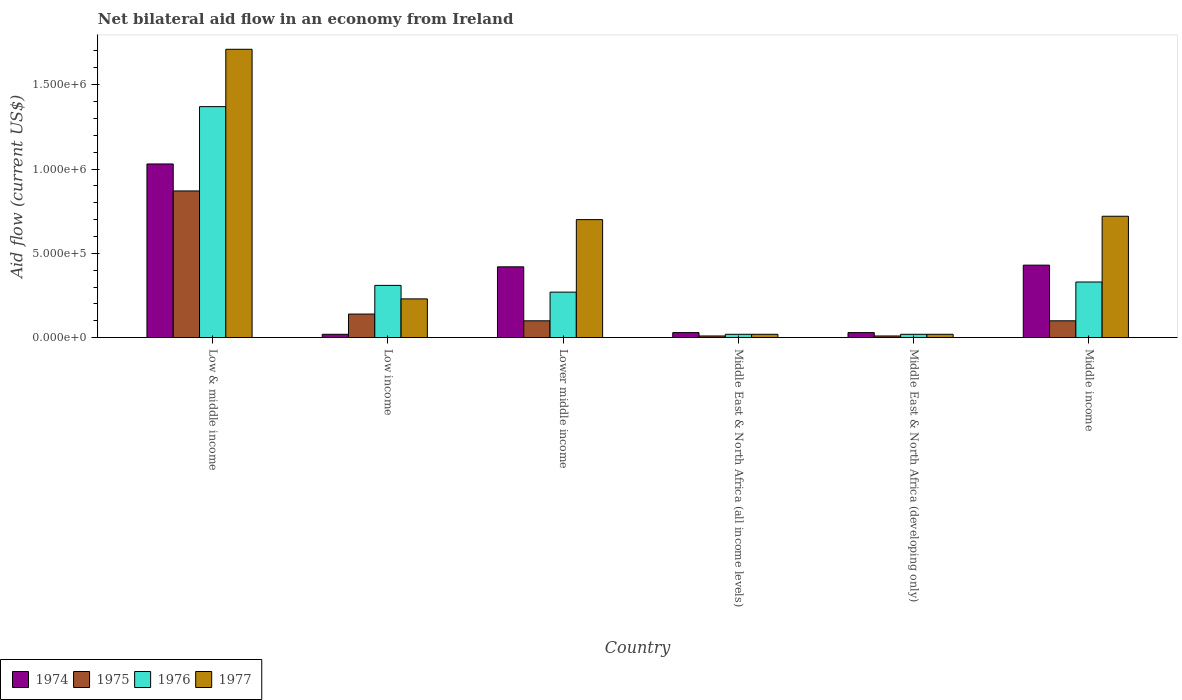Are the number of bars per tick equal to the number of legend labels?
Provide a succinct answer. Yes. Are the number of bars on each tick of the X-axis equal?
Keep it short and to the point. Yes. What is the label of the 1st group of bars from the left?
Provide a short and direct response. Low & middle income. In how many cases, is the number of bars for a given country not equal to the number of legend labels?
Keep it short and to the point. 0. What is the net bilateral aid flow in 1977 in Low income?
Provide a succinct answer. 2.30e+05. Across all countries, what is the maximum net bilateral aid flow in 1976?
Your response must be concise. 1.37e+06. Across all countries, what is the minimum net bilateral aid flow in 1974?
Give a very brief answer. 2.00e+04. In which country was the net bilateral aid flow in 1976 minimum?
Provide a short and direct response. Middle East & North Africa (all income levels). What is the total net bilateral aid flow in 1974 in the graph?
Ensure brevity in your answer.  1.96e+06. What is the difference between the net bilateral aid flow in 1974 in Middle East & North Africa (all income levels) and that in Middle East & North Africa (developing only)?
Offer a terse response. 0. What is the difference between the net bilateral aid flow in 1975 in Lower middle income and the net bilateral aid flow in 1974 in Low & middle income?
Offer a very short reply. -9.30e+05. What is the average net bilateral aid flow in 1975 per country?
Provide a succinct answer. 2.05e+05. What is the difference between the net bilateral aid flow of/in 1975 and net bilateral aid flow of/in 1976 in Lower middle income?
Give a very brief answer. -1.70e+05. In how many countries, is the net bilateral aid flow in 1975 greater than 800000 US$?
Ensure brevity in your answer.  1. What is the ratio of the net bilateral aid flow in 1977 in Low income to that in Middle East & North Africa (all income levels)?
Give a very brief answer. 11.5. Is the net bilateral aid flow in 1975 in Lower middle income less than that in Middle East & North Africa (all income levels)?
Your answer should be compact. No. Is the difference between the net bilateral aid flow in 1975 in Low income and Middle East & North Africa (developing only) greater than the difference between the net bilateral aid flow in 1976 in Low income and Middle East & North Africa (developing only)?
Ensure brevity in your answer.  No. What is the difference between the highest and the second highest net bilateral aid flow in 1976?
Offer a terse response. 1.04e+06. What is the difference between the highest and the lowest net bilateral aid flow in 1976?
Your answer should be compact. 1.35e+06. Is it the case that in every country, the sum of the net bilateral aid flow in 1974 and net bilateral aid flow in 1977 is greater than the sum of net bilateral aid flow in 1976 and net bilateral aid flow in 1975?
Your answer should be compact. No. What does the 2nd bar from the left in Middle income represents?
Offer a very short reply. 1975. What does the 3rd bar from the right in Low income represents?
Ensure brevity in your answer.  1975. Is it the case that in every country, the sum of the net bilateral aid flow in 1975 and net bilateral aid flow in 1977 is greater than the net bilateral aid flow in 1974?
Make the answer very short. No. Are all the bars in the graph horizontal?
Provide a short and direct response. No. Where does the legend appear in the graph?
Offer a terse response. Bottom left. How many legend labels are there?
Give a very brief answer. 4. How are the legend labels stacked?
Make the answer very short. Horizontal. What is the title of the graph?
Give a very brief answer. Net bilateral aid flow in an economy from Ireland. What is the label or title of the Y-axis?
Offer a very short reply. Aid flow (current US$). What is the Aid flow (current US$) in 1974 in Low & middle income?
Provide a succinct answer. 1.03e+06. What is the Aid flow (current US$) in 1975 in Low & middle income?
Make the answer very short. 8.70e+05. What is the Aid flow (current US$) in 1976 in Low & middle income?
Offer a very short reply. 1.37e+06. What is the Aid flow (current US$) of 1977 in Low & middle income?
Provide a short and direct response. 1.71e+06. What is the Aid flow (current US$) of 1974 in Low income?
Provide a short and direct response. 2.00e+04. What is the Aid flow (current US$) of 1977 in Low income?
Provide a succinct answer. 2.30e+05. What is the Aid flow (current US$) in 1974 in Lower middle income?
Provide a succinct answer. 4.20e+05. What is the Aid flow (current US$) in 1975 in Lower middle income?
Provide a succinct answer. 1.00e+05. What is the Aid flow (current US$) of 1976 in Lower middle income?
Your answer should be compact. 2.70e+05. What is the Aid flow (current US$) of 1975 in Middle East & North Africa (all income levels)?
Ensure brevity in your answer.  10000. What is the Aid flow (current US$) of 1976 in Middle East & North Africa (all income levels)?
Your answer should be very brief. 2.00e+04. What is the Aid flow (current US$) in 1977 in Middle East & North Africa (all income levels)?
Your response must be concise. 2.00e+04. What is the Aid flow (current US$) of 1974 in Middle East & North Africa (developing only)?
Ensure brevity in your answer.  3.00e+04. What is the Aid flow (current US$) in 1975 in Middle East & North Africa (developing only)?
Give a very brief answer. 10000. What is the Aid flow (current US$) of 1976 in Middle East & North Africa (developing only)?
Keep it short and to the point. 2.00e+04. What is the Aid flow (current US$) in 1977 in Middle East & North Africa (developing only)?
Your response must be concise. 2.00e+04. What is the Aid flow (current US$) in 1975 in Middle income?
Keep it short and to the point. 1.00e+05. What is the Aid flow (current US$) of 1976 in Middle income?
Provide a succinct answer. 3.30e+05. What is the Aid flow (current US$) in 1977 in Middle income?
Provide a short and direct response. 7.20e+05. Across all countries, what is the maximum Aid flow (current US$) in 1974?
Give a very brief answer. 1.03e+06. Across all countries, what is the maximum Aid flow (current US$) in 1975?
Offer a very short reply. 8.70e+05. Across all countries, what is the maximum Aid flow (current US$) of 1976?
Offer a terse response. 1.37e+06. Across all countries, what is the maximum Aid flow (current US$) in 1977?
Provide a short and direct response. 1.71e+06. Across all countries, what is the minimum Aid flow (current US$) in 1974?
Your answer should be compact. 2.00e+04. Across all countries, what is the minimum Aid flow (current US$) of 1976?
Ensure brevity in your answer.  2.00e+04. Across all countries, what is the minimum Aid flow (current US$) in 1977?
Your response must be concise. 2.00e+04. What is the total Aid flow (current US$) in 1974 in the graph?
Offer a very short reply. 1.96e+06. What is the total Aid flow (current US$) in 1975 in the graph?
Keep it short and to the point. 1.23e+06. What is the total Aid flow (current US$) in 1976 in the graph?
Offer a very short reply. 2.32e+06. What is the total Aid flow (current US$) of 1977 in the graph?
Offer a terse response. 3.40e+06. What is the difference between the Aid flow (current US$) in 1974 in Low & middle income and that in Low income?
Offer a very short reply. 1.01e+06. What is the difference between the Aid flow (current US$) in 1975 in Low & middle income and that in Low income?
Offer a terse response. 7.30e+05. What is the difference between the Aid flow (current US$) of 1976 in Low & middle income and that in Low income?
Make the answer very short. 1.06e+06. What is the difference between the Aid flow (current US$) of 1977 in Low & middle income and that in Low income?
Provide a succinct answer. 1.48e+06. What is the difference between the Aid flow (current US$) in 1975 in Low & middle income and that in Lower middle income?
Make the answer very short. 7.70e+05. What is the difference between the Aid flow (current US$) of 1976 in Low & middle income and that in Lower middle income?
Make the answer very short. 1.10e+06. What is the difference between the Aid flow (current US$) of 1977 in Low & middle income and that in Lower middle income?
Ensure brevity in your answer.  1.01e+06. What is the difference between the Aid flow (current US$) in 1974 in Low & middle income and that in Middle East & North Africa (all income levels)?
Provide a succinct answer. 1.00e+06. What is the difference between the Aid flow (current US$) of 1975 in Low & middle income and that in Middle East & North Africa (all income levels)?
Provide a short and direct response. 8.60e+05. What is the difference between the Aid flow (current US$) in 1976 in Low & middle income and that in Middle East & North Africa (all income levels)?
Your response must be concise. 1.35e+06. What is the difference between the Aid flow (current US$) in 1977 in Low & middle income and that in Middle East & North Africa (all income levels)?
Provide a succinct answer. 1.69e+06. What is the difference between the Aid flow (current US$) of 1975 in Low & middle income and that in Middle East & North Africa (developing only)?
Keep it short and to the point. 8.60e+05. What is the difference between the Aid flow (current US$) in 1976 in Low & middle income and that in Middle East & North Africa (developing only)?
Offer a terse response. 1.35e+06. What is the difference between the Aid flow (current US$) in 1977 in Low & middle income and that in Middle East & North Africa (developing only)?
Your answer should be compact. 1.69e+06. What is the difference between the Aid flow (current US$) of 1974 in Low & middle income and that in Middle income?
Offer a terse response. 6.00e+05. What is the difference between the Aid flow (current US$) of 1975 in Low & middle income and that in Middle income?
Keep it short and to the point. 7.70e+05. What is the difference between the Aid flow (current US$) in 1976 in Low & middle income and that in Middle income?
Make the answer very short. 1.04e+06. What is the difference between the Aid flow (current US$) in 1977 in Low & middle income and that in Middle income?
Make the answer very short. 9.90e+05. What is the difference between the Aid flow (current US$) of 1974 in Low income and that in Lower middle income?
Provide a succinct answer. -4.00e+05. What is the difference between the Aid flow (current US$) in 1976 in Low income and that in Lower middle income?
Give a very brief answer. 4.00e+04. What is the difference between the Aid flow (current US$) of 1977 in Low income and that in Lower middle income?
Your response must be concise. -4.70e+05. What is the difference between the Aid flow (current US$) of 1975 in Low income and that in Middle East & North Africa (all income levels)?
Offer a very short reply. 1.30e+05. What is the difference between the Aid flow (current US$) in 1976 in Low income and that in Middle East & North Africa (all income levels)?
Ensure brevity in your answer.  2.90e+05. What is the difference between the Aid flow (current US$) of 1977 in Low income and that in Middle East & North Africa (all income levels)?
Offer a terse response. 2.10e+05. What is the difference between the Aid flow (current US$) of 1974 in Low income and that in Middle East & North Africa (developing only)?
Your response must be concise. -10000. What is the difference between the Aid flow (current US$) of 1975 in Low income and that in Middle East & North Africa (developing only)?
Ensure brevity in your answer.  1.30e+05. What is the difference between the Aid flow (current US$) in 1976 in Low income and that in Middle East & North Africa (developing only)?
Ensure brevity in your answer.  2.90e+05. What is the difference between the Aid flow (current US$) in 1974 in Low income and that in Middle income?
Provide a succinct answer. -4.10e+05. What is the difference between the Aid flow (current US$) of 1976 in Low income and that in Middle income?
Ensure brevity in your answer.  -2.00e+04. What is the difference between the Aid flow (current US$) of 1977 in Low income and that in Middle income?
Give a very brief answer. -4.90e+05. What is the difference between the Aid flow (current US$) in 1976 in Lower middle income and that in Middle East & North Africa (all income levels)?
Make the answer very short. 2.50e+05. What is the difference between the Aid flow (current US$) of 1977 in Lower middle income and that in Middle East & North Africa (all income levels)?
Offer a terse response. 6.80e+05. What is the difference between the Aid flow (current US$) of 1974 in Lower middle income and that in Middle East & North Africa (developing only)?
Provide a succinct answer. 3.90e+05. What is the difference between the Aid flow (current US$) in 1975 in Lower middle income and that in Middle East & North Africa (developing only)?
Give a very brief answer. 9.00e+04. What is the difference between the Aid flow (current US$) of 1976 in Lower middle income and that in Middle East & North Africa (developing only)?
Your answer should be very brief. 2.50e+05. What is the difference between the Aid flow (current US$) of 1977 in Lower middle income and that in Middle East & North Africa (developing only)?
Make the answer very short. 6.80e+05. What is the difference between the Aid flow (current US$) in 1974 in Lower middle income and that in Middle income?
Your answer should be compact. -10000. What is the difference between the Aid flow (current US$) of 1976 in Lower middle income and that in Middle income?
Your answer should be very brief. -6.00e+04. What is the difference between the Aid flow (current US$) of 1977 in Middle East & North Africa (all income levels) and that in Middle East & North Africa (developing only)?
Ensure brevity in your answer.  0. What is the difference between the Aid flow (current US$) of 1974 in Middle East & North Africa (all income levels) and that in Middle income?
Your response must be concise. -4.00e+05. What is the difference between the Aid flow (current US$) of 1975 in Middle East & North Africa (all income levels) and that in Middle income?
Offer a terse response. -9.00e+04. What is the difference between the Aid flow (current US$) in 1976 in Middle East & North Africa (all income levels) and that in Middle income?
Offer a terse response. -3.10e+05. What is the difference between the Aid flow (current US$) in 1977 in Middle East & North Africa (all income levels) and that in Middle income?
Provide a short and direct response. -7.00e+05. What is the difference between the Aid flow (current US$) in 1974 in Middle East & North Africa (developing only) and that in Middle income?
Offer a very short reply. -4.00e+05. What is the difference between the Aid flow (current US$) in 1976 in Middle East & North Africa (developing only) and that in Middle income?
Ensure brevity in your answer.  -3.10e+05. What is the difference between the Aid flow (current US$) in 1977 in Middle East & North Africa (developing only) and that in Middle income?
Your answer should be very brief. -7.00e+05. What is the difference between the Aid flow (current US$) of 1974 in Low & middle income and the Aid flow (current US$) of 1975 in Low income?
Your answer should be compact. 8.90e+05. What is the difference between the Aid flow (current US$) of 1974 in Low & middle income and the Aid flow (current US$) of 1976 in Low income?
Make the answer very short. 7.20e+05. What is the difference between the Aid flow (current US$) in 1975 in Low & middle income and the Aid flow (current US$) in 1976 in Low income?
Your response must be concise. 5.60e+05. What is the difference between the Aid flow (current US$) in 1975 in Low & middle income and the Aid flow (current US$) in 1977 in Low income?
Your response must be concise. 6.40e+05. What is the difference between the Aid flow (current US$) of 1976 in Low & middle income and the Aid flow (current US$) of 1977 in Low income?
Your response must be concise. 1.14e+06. What is the difference between the Aid flow (current US$) in 1974 in Low & middle income and the Aid flow (current US$) in 1975 in Lower middle income?
Your answer should be very brief. 9.30e+05. What is the difference between the Aid flow (current US$) of 1974 in Low & middle income and the Aid flow (current US$) of 1976 in Lower middle income?
Offer a terse response. 7.60e+05. What is the difference between the Aid flow (current US$) in 1975 in Low & middle income and the Aid flow (current US$) in 1977 in Lower middle income?
Your response must be concise. 1.70e+05. What is the difference between the Aid flow (current US$) of 1976 in Low & middle income and the Aid flow (current US$) of 1977 in Lower middle income?
Your response must be concise. 6.70e+05. What is the difference between the Aid flow (current US$) in 1974 in Low & middle income and the Aid flow (current US$) in 1975 in Middle East & North Africa (all income levels)?
Offer a terse response. 1.02e+06. What is the difference between the Aid flow (current US$) in 1974 in Low & middle income and the Aid flow (current US$) in 1976 in Middle East & North Africa (all income levels)?
Your answer should be very brief. 1.01e+06. What is the difference between the Aid flow (current US$) in 1974 in Low & middle income and the Aid flow (current US$) in 1977 in Middle East & North Africa (all income levels)?
Your response must be concise. 1.01e+06. What is the difference between the Aid flow (current US$) in 1975 in Low & middle income and the Aid flow (current US$) in 1976 in Middle East & North Africa (all income levels)?
Offer a terse response. 8.50e+05. What is the difference between the Aid flow (current US$) of 1975 in Low & middle income and the Aid flow (current US$) of 1977 in Middle East & North Africa (all income levels)?
Your response must be concise. 8.50e+05. What is the difference between the Aid flow (current US$) in 1976 in Low & middle income and the Aid flow (current US$) in 1977 in Middle East & North Africa (all income levels)?
Offer a terse response. 1.35e+06. What is the difference between the Aid flow (current US$) in 1974 in Low & middle income and the Aid flow (current US$) in 1975 in Middle East & North Africa (developing only)?
Offer a very short reply. 1.02e+06. What is the difference between the Aid flow (current US$) in 1974 in Low & middle income and the Aid flow (current US$) in 1976 in Middle East & North Africa (developing only)?
Your answer should be very brief. 1.01e+06. What is the difference between the Aid flow (current US$) in 1974 in Low & middle income and the Aid flow (current US$) in 1977 in Middle East & North Africa (developing only)?
Offer a terse response. 1.01e+06. What is the difference between the Aid flow (current US$) in 1975 in Low & middle income and the Aid flow (current US$) in 1976 in Middle East & North Africa (developing only)?
Your answer should be very brief. 8.50e+05. What is the difference between the Aid flow (current US$) of 1975 in Low & middle income and the Aid flow (current US$) of 1977 in Middle East & North Africa (developing only)?
Offer a very short reply. 8.50e+05. What is the difference between the Aid flow (current US$) in 1976 in Low & middle income and the Aid flow (current US$) in 1977 in Middle East & North Africa (developing only)?
Offer a very short reply. 1.35e+06. What is the difference between the Aid flow (current US$) of 1974 in Low & middle income and the Aid flow (current US$) of 1975 in Middle income?
Your answer should be compact. 9.30e+05. What is the difference between the Aid flow (current US$) of 1974 in Low & middle income and the Aid flow (current US$) of 1977 in Middle income?
Your answer should be very brief. 3.10e+05. What is the difference between the Aid flow (current US$) in 1975 in Low & middle income and the Aid flow (current US$) in 1976 in Middle income?
Your response must be concise. 5.40e+05. What is the difference between the Aid flow (current US$) of 1976 in Low & middle income and the Aid flow (current US$) of 1977 in Middle income?
Provide a succinct answer. 6.50e+05. What is the difference between the Aid flow (current US$) of 1974 in Low income and the Aid flow (current US$) of 1975 in Lower middle income?
Keep it short and to the point. -8.00e+04. What is the difference between the Aid flow (current US$) in 1974 in Low income and the Aid flow (current US$) in 1977 in Lower middle income?
Offer a terse response. -6.80e+05. What is the difference between the Aid flow (current US$) of 1975 in Low income and the Aid flow (current US$) of 1977 in Lower middle income?
Your answer should be very brief. -5.60e+05. What is the difference between the Aid flow (current US$) in 1976 in Low income and the Aid flow (current US$) in 1977 in Lower middle income?
Your answer should be compact. -3.90e+05. What is the difference between the Aid flow (current US$) in 1974 in Low income and the Aid flow (current US$) in 1975 in Middle East & North Africa (all income levels)?
Ensure brevity in your answer.  10000. What is the difference between the Aid flow (current US$) of 1974 in Low income and the Aid flow (current US$) of 1976 in Middle East & North Africa (all income levels)?
Give a very brief answer. 0. What is the difference between the Aid flow (current US$) of 1975 in Low income and the Aid flow (current US$) of 1976 in Middle East & North Africa (all income levels)?
Make the answer very short. 1.20e+05. What is the difference between the Aid flow (current US$) of 1975 in Low income and the Aid flow (current US$) of 1977 in Middle East & North Africa (all income levels)?
Your response must be concise. 1.20e+05. What is the difference between the Aid flow (current US$) in 1974 in Low income and the Aid flow (current US$) in 1975 in Middle East & North Africa (developing only)?
Offer a very short reply. 10000. What is the difference between the Aid flow (current US$) of 1976 in Low income and the Aid flow (current US$) of 1977 in Middle East & North Africa (developing only)?
Offer a very short reply. 2.90e+05. What is the difference between the Aid flow (current US$) of 1974 in Low income and the Aid flow (current US$) of 1976 in Middle income?
Provide a succinct answer. -3.10e+05. What is the difference between the Aid flow (current US$) of 1974 in Low income and the Aid flow (current US$) of 1977 in Middle income?
Offer a terse response. -7.00e+05. What is the difference between the Aid flow (current US$) of 1975 in Low income and the Aid flow (current US$) of 1976 in Middle income?
Keep it short and to the point. -1.90e+05. What is the difference between the Aid flow (current US$) of 1975 in Low income and the Aid flow (current US$) of 1977 in Middle income?
Offer a terse response. -5.80e+05. What is the difference between the Aid flow (current US$) of 1976 in Low income and the Aid flow (current US$) of 1977 in Middle income?
Ensure brevity in your answer.  -4.10e+05. What is the difference between the Aid flow (current US$) in 1975 in Lower middle income and the Aid flow (current US$) in 1976 in Middle East & North Africa (all income levels)?
Give a very brief answer. 8.00e+04. What is the difference between the Aid flow (current US$) of 1975 in Lower middle income and the Aid flow (current US$) of 1977 in Middle East & North Africa (all income levels)?
Provide a short and direct response. 8.00e+04. What is the difference between the Aid flow (current US$) of 1976 in Lower middle income and the Aid flow (current US$) of 1977 in Middle East & North Africa (all income levels)?
Make the answer very short. 2.50e+05. What is the difference between the Aid flow (current US$) of 1974 in Lower middle income and the Aid flow (current US$) of 1976 in Middle East & North Africa (developing only)?
Provide a short and direct response. 4.00e+05. What is the difference between the Aid flow (current US$) of 1974 in Lower middle income and the Aid flow (current US$) of 1977 in Middle East & North Africa (developing only)?
Give a very brief answer. 4.00e+05. What is the difference between the Aid flow (current US$) in 1975 in Lower middle income and the Aid flow (current US$) in 1976 in Middle East & North Africa (developing only)?
Give a very brief answer. 8.00e+04. What is the difference between the Aid flow (current US$) of 1975 in Lower middle income and the Aid flow (current US$) of 1977 in Middle East & North Africa (developing only)?
Provide a short and direct response. 8.00e+04. What is the difference between the Aid flow (current US$) in 1976 in Lower middle income and the Aid flow (current US$) in 1977 in Middle East & North Africa (developing only)?
Provide a short and direct response. 2.50e+05. What is the difference between the Aid flow (current US$) of 1974 in Lower middle income and the Aid flow (current US$) of 1975 in Middle income?
Provide a short and direct response. 3.20e+05. What is the difference between the Aid flow (current US$) in 1974 in Lower middle income and the Aid flow (current US$) in 1977 in Middle income?
Your answer should be very brief. -3.00e+05. What is the difference between the Aid flow (current US$) in 1975 in Lower middle income and the Aid flow (current US$) in 1976 in Middle income?
Make the answer very short. -2.30e+05. What is the difference between the Aid flow (current US$) of 1975 in Lower middle income and the Aid flow (current US$) of 1977 in Middle income?
Ensure brevity in your answer.  -6.20e+05. What is the difference between the Aid flow (current US$) of 1976 in Lower middle income and the Aid flow (current US$) of 1977 in Middle income?
Your response must be concise. -4.50e+05. What is the difference between the Aid flow (current US$) in 1974 in Middle East & North Africa (all income levels) and the Aid flow (current US$) in 1976 in Middle East & North Africa (developing only)?
Make the answer very short. 10000. What is the difference between the Aid flow (current US$) in 1975 in Middle East & North Africa (all income levels) and the Aid flow (current US$) in 1977 in Middle East & North Africa (developing only)?
Provide a short and direct response. -10000. What is the difference between the Aid flow (current US$) in 1976 in Middle East & North Africa (all income levels) and the Aid flow (current US$) in 1977 in Middle East & North Africa (developing only)?
Give a very brief answer. 0. What is the difference between the Aid flow (current US$) of 1974 in Middle East & North Africa (all income levels) and the Aid flow (current US$) of 1976 in Middle income?
Your answer should be compact. -3.00e+05. What is the difference between the Aid flow (current US$) of 1974 in Middle East & North Africa (all income levels) and the Aid flow (current US$) of 1977 in Middle income?
Ensure brevity in your answer.  -6.90e+05. What is the difference between the Aid flow (current US$) in 1975 in Middle East & North Africa (all income levels) and the Aid flow (current US$) in 1976 in Middle income?
Provide a succinct answer. -3.20e+05. What is the difference between the Aid flow (current US$) of 1975 in Middle East & North Africa (all income levels) and the Aid flow (current US$) of 1977 in Middle income?
Your answer should be compact. -7.10e+05. What is the difference between the Aid flow (current US$) of 1976 in Middle East & North Africa (all income levels) and the Aid flow (current US$) of 1977 in Middle income?
Your response must be concise. -7.00e+05. What is the difference between the Aid flow (current US$) of 1974 in Middle East & North Africa (developing only) and the Aid flow (current US$) of 1975 in Middle income?
Offer a terse response. -7.00e+04. What is the difference between the Aid flow (current US$) of 1974 in Middle East & North Africa (developing only) and the Aid flow (current US$) of 1977 in Middle income?
Provide a short and direct response. -6.90e+05. What is the difference between the Aid flow (current US$) in 1975 in Middle East & North Africa (developing only) and the Aid flow (current US$) in 1976 in Middle income?
Your answer should be compact. -3.20e+05. What is the difference between the Aid flow (current US$) in 1975 in Middle East & North Africa (developing only) and the Aid flow (current US$) in 1977 in Middle income?
Keep it short and to the point. -7.10e+05. What is the difference between the Aid flow (current US$) of 1976 in Middle East & North Africa (developing only) and the Aid flow (current US$) of 1977 in Middle income?
Offer a very short reply. -7.00e+05. What is the average Aid flow (current US$) in 1974 per country?
Make the answer very short. 3.27e+05. What is the average Aid flow (current US$) of 1975 per country?
Your answer should be very brief. 2.05e+05. What is the average Aid flow (current US$) of 1976 per country?
Your response must be concise. 3.87e+05. What is the average Aid flow (current US$) in 1977 per country?
Give a very brief answer. 5.67e+05. What is the difference between the Aid flow (current US$) in 1974 and Aid flow (current US$) in 1975 in Low & middle income?
Your answer should be compact. 1.60e+05. What is the difference between the Aid flow (current US$) in 1974 and Aid flow (current US$) in 1977 in Low & middle income?
Offer a terse response. -6.80e+05. What is the difference between the Aid flow (current US$) of 1975 and Aid flow (current US$) of 1976 in Low & middle income?
Offer a terse response. -5.00e+05. What is the difference between the Aid flow (current US$) in 1975 and Aid flow (current US$) in 1977 in Low & middle income?
Give a very brief answer. -8.40e+05. What is the difference between the Aid flow (current US$) of 1976 and Aid flow (current US$) of 1977 in Low & middle income?
Give a very brief answer. -3.40e+05. What is the difference between the Aid flow (current US$) in 1974 and Aid flow (current US$) in 1976 in Low income?
Give a very brief answer. -2.90e+05. What is the difference between the Aid flow (current US$) of 1974 and Aid flow (current US$) of 1977 in Low income?
Your answer should be very brief. -2.10e+05. What is the difference between the Aid flow (current US$) in 1975 and Aid flow (current US$) in 1977 in Low income?
Make the answer very short. -9.00e+04. What is the difference between the Aid flow (current US$) in 1974 and Aid flow (current US$) in 1975 in Lower middle income?
Make the answer very short. 3.20e+05. What is the difference between the Aid flow (current US$) in 1974 and Aid flow (current US$) in 1977 in Lower middle income?
Give a very brief answer. -2.80e+05. What is the difference between the Aid flow (current US$) in 1975 and Aid flow (current US$) in 1976 in Lower middle income?
Your response must be concise. -1.70e+05. What is the difference between the Aid flow (current US$) of 1975 and Aid flow (current US$) of 1977 in Lower middle income?
Your answer should be very brief. -6.00e+05. What is the difference between the Aid flow (current US$) of 1976 and Aid flow (current US$) of 1977 in Lower middle income?
Ensure brevity in your answer.  -4.30e+05. What is the difference between the Aid flow (current US$) of 1974 and Aid flow (current US$) of 1976 in Middle East & North Africa (all income levels)?
Your answer should be compact. 10000. What is the difference between the Aid flow (current US$) in 1974 and Aid flow (current US$) in 1977 in Middle East & North Africa (all income levels)?
Ensure brevity in your answer.  10000. What is the difference between the Aid flow (current US$) of 1975 and Aid flow (current US$) of 1976 in Middle East & North Africa (all income levels)?
Your answer should be compact. -10000. What is the difference between the Aid flow (current US$) in 1975 and Aid flow (current US$) in 1977 in Middle East & North Africa (all income levels)?
Your answer should be very brief. -10000. What is the difference between the Aid flow (current US$) of 1974 and Aid flow (current US$) of 1976 in Middle East & North Africa (developing only)?
Your answer should be compact. 10000. What is the difference between the Aid flow (current US$) of 1974 and Aid flow (current US$) of 1977 in Middle East & North Africa (developing only)?
Provide a succinct answer. 10000. What is the difference between the Aid flow (current US$) of 1975 and Aid flow (current US$) of 1976 in Middle East & North Africa (developing only)?
Your response must be concise. -10000. What is the difference between the Aid flow (current US$) of 1975 and Aid flow (current US$) of 1977 in Middle East & North Africa (developing only)?
Offer a very short reply. -10000. What is the difference between the Aid flow (current US$) in 1975 and Aid flow (current US$) in 1976 in Middle income?
Offer a terse response. -2.30e+05. What is the difference between the Aid flow (current US$) of 1975 and Aid flow (current US$) of 1977 in Middle income?
Offer a terse response. -6.20e+05. What is the difference between the Aid flow (current US$) in 1976 and Aid flow (current US$) in 1977 in Middle income?
Provide a succinct answer. -3.90e+05. What is the ratio of the Aid flow (current US$) of 1974 in Low & middle income to that in Low income?
Make the answer very short. 51.5. What is the ratio of the Aid flow (current US$) of 1975 in Low & middle income to that in Low income?
Your answer should be very brief. 6.21. What is the ratio of the Aid flow (current US$) of 1976 in Low & middle income to that in Low income?
Your answer should be compact. 4.42. What is the ratio of the Aid flow (current US$) of 1977 in Low & middle income to that in Low income?
Provide a short and direct response. 7.43. What is the ratio of the Aid flow (current US$) of 1974 in Low & middle income to that in Lower middle income?
Provide a succinct answer. 2.45. What is the ratio of the Aid flow (current US$) of 1976 in Low & middle income to that in Lower middle income?
Your answer should be compact. 5.07. What is the ratio of the Aid flow (current US$) in 1977 in Low & middle income to that in Lower middle income?
Your answer should be compact. 2.44. What is the ratio of the Aid flow (current US$) of 1974 in Low & middle income to that in Middle East & North Africa (all income levels)?
Keep it short and to the point. 34.33. What is the ratio of the Aid flow (current US$) in 1975 in Low & middle income to that in Middle East & North Africa (all income levels)?
Your answer should be compact. 87. What is the ratio of the Aid flow (current US$) in 1976 in Low & middle income to that in Middle East & North Africa (all income levels)?
Give a very brief answer. 68.5. What is the ratio of the Aid flow (current US$) in 1977 in Low & middle income to that in Middle East & North Africa (all income levels)?
Your answer should be compact. 85.5. What is the ratio of the Aid flow (current US$) of 1974 in Low & middle income to that in Middle East & North Africa (developing only)?
Your response must be concise. 34.33. What is the ratio of the Aid flow (current US$) of 1975 in Low & middle income to that in Middle East & North Africa (developing only)?
Give a very brief answer. 87. What is the ratio of the Aid flow (current US$) of 1976 in Low & middle income to that in Middle East & North Africa (developing only)?
Provide a succinct answer. 68.5. What is the ratio of the Aid flow (current US$) in 1977 in Low & middle income to that in Middle East & North Africa (developing only)?
Provide a succinct answer. 85.5. What is the ratio of the Aid flow (current US$) in 1974 in Low & middle income to that in Middle income?
Make the answer very short. 2.4. What is the ratio of the Aid flow (current US$) of 1976 in Low & middle income to that in Middle income?
Ensure brevity in your answer.  4.15. What is the ratio of the Aid flow (current US$) of 1977 in Low & middle income to that in Middle income?
Keep it short and to the point. 2.38. What is the ratio of the Aid flow (current US$) in 1974 in Low income to that in Lower middle income?
Keep it short and to the point. 0.05. What is the ratio of the Aid flow (current US$) of 1975 in Low income to that in Lower middle income?
Keep it short and to the point. 1.4. What is the ratio of the Aid flow (current US$) of 1976 in Low income to that in Lower middle income?
Provide a short and direct response. 1.15. What is the ratio of the Aid flow (current US$) in 1977 in Low income to that in Lower middle income?
Provide a short and direct response. 0.33. What is the ratio of the Aid flow (current US$) of 1975 in Low income to that in Middle East & North Africa (all income levels)?
Keep it short and to the point. 14. What is the ratio of the Aid flow (current US$) of 1976 in Low income to that in Middle East & North Africa (all income levels)?
Keep it short and to the point. 15.5. What is the ratio of the Aid flow (current US$) in 1977 in Low income to that in Middle East & North Africa (all income levels)?
Your answer should be very brief. 11.5. What is the ratio of the Aid flow (current US$) of 1974 in Low income to that in Middle East & North Africa (developing only)?
Your answer should be compact. 0.67. What is the ratio of the Aid flow (current US$) of 1975 in Low income to that in Middle East & North Africa (developing only)?
Your answer should be compact. 14. What is the ratio of the Aid flow (current US$) of 1974 in Low income to that in Middle income?
Keep it short and to the point. 0.05. What is the ratio of the Aid flow (current US$) in 1976 in Low income to that in Middle income?
Your response must be concise. 0.94. What is the ratio of the Aid flow (current US$) of 1977 in Low income to that in Middle income?
Keep it short and to the point. 0.32. What is the ratio of the Aid flow (current US$) in 1975 in Lower middle income to that in Middle East & North Africa (developing only)?
Provide a short and direct response. 10. What is the ratio of the Aid flow (current US$) in 1976 in Lower middle income to that in Middle East & North Africa (developing only)?
Give a very brief answer. 13.5. What is the ratio of the Aid flow (current US$) of 1977 in Lower middle income to that in Middle East & North Africa (developing only)?
Provide a short and direct response. 35. What is the ratio of the Aid flow (current US$) of 1974 in Lower middle income to that in Middle income?
Ensure brevity in your answer.  0.98. What is the ratio of the Aid flow (current US$) in 1975 in Lower middle income to that in Middle income?
Your answer should be compact. 1. What is the ratio of the Aid flow (current US$) in 1976 in Lower middle income to that in Middle income?
Give a very brief answer. 0.82. What is the ratio of the Aid flow (current US$) of 1977 in Lower middle income to that in Middle income?
Provide a short and direct response. 0.97. What is the ratio of the Aid flow (current US$) in 1975 in Middle East & North Africa (all income levels) to that in Middle East & North Africa (developing only)?
Keep it short and to the point. 1. What is the ratio of the Aid flow (current US$) of 1976 in Middle East & North Africa (all income levels) to that in Middle East & North Africa (developing only)?
Provide a short and direct response. 1. What is the ratio of the Aid flow (current US$) of 1977 in Middle East & North Africa (all income levels) to that in Middle East & North Africa (developing only)?
Give a very brief answer. 1. What is the ratio of the Aid flow (current US$) of 1974 in Middle East & North Africa (all income levels) to that in Middle income?
Provide a short and direct response. 0.07. What is the ratio of the Aid flow (current US$) in 1975 in Middle East & North Africa (all income levels) to that in Middle income?
Provide a succinct answer. 0.1. What is the ratio of the Aid flow (current US$) of 1976 in Middle East & North Africa (all income levels) to that in Middle income?
Ensure brevity in your answer.  0.06. What is the ratio of the Aid flow (current US$) in 1977 in Middle East & North Africa (all income levels) to that in Middle income?
Offer a very short reply. 0.03. What is the ratio of the Aid flow (current US$) of 1974 in Middle East & North Africa (developing only) to that in Middle income?
Your answer should be compact. 0.07. What is the ratio of the Aid flow (current US$) in 1976 in Middle East & North Africa (developing only) to that in Middle income?
Make the answer very short. 0.06. What is the ratio of the Aid flow (current US$) of 1977 in Middle East & North Africa (developing only) to that in Middle income?
Keep it short and to the point. 0.03. What is the difference between the highest and the second highest Aid flow (current US$) of 1974?
Your answer should be very brief. 6.00e+05. What is the difference between the highest and the second highest Aid flow (current US$) in 1975?
Your response must be concise. 7.30e+05. What is the difference between the highest and the second highest Aid flow (current US$) in 1976?
Provide a short and direct response. 1.04e+06. What is the difference between the highest and the second highest Aid flow (current US$) of 1977?
Offer a very short reply. 9.90e+05. What is the difference between the highest and the lowest Aid flow (current US$) of 1974?
Provide a succinct answer. 1.01e+06. What is the difference between the highest and the lowest Aid flow (current US$) of 1975?
Provide a short and direct response. 8.60e+05. What is the difference between the highest and the lowest Aid flow (current US$) in 1976?
Offer a very short reply. 1.35e+06. What is the difference between the highest and the lowest Aid flow (current US$) in 1977?
Provide a succinct answer. 1.69e+06. 